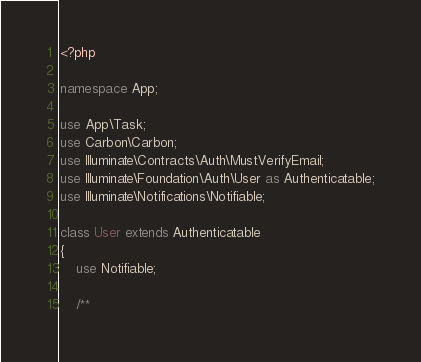Convert code to text. <code><loc_0><loc_0><loc_500><loc_500><_PHP_><?php

namespace App;

use App\Task;
use Carbon\Carbon;
use Illuminate\Contracts\Auth\MustVerifyEmail;
use Illuminate\Foundation\Auth\User as Authenticatable;
use Illuminate\Notifications\Notifiable;

class User extends Authenticatable
{
    use Notifiable;

    /**</code> 